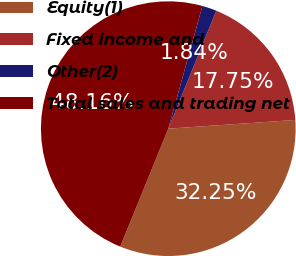<chart> <loc_0><loc_0><loc_500><loc_500><pie_chart><fcel>Equity(1)<fcel>Fixed income and<fcel>Other(2)<fcel>Total sales and trading net<nl><fcel>32.25%<fcel>17.75%<fcel>1.84%<fcel>48.16%<nl></chart> 